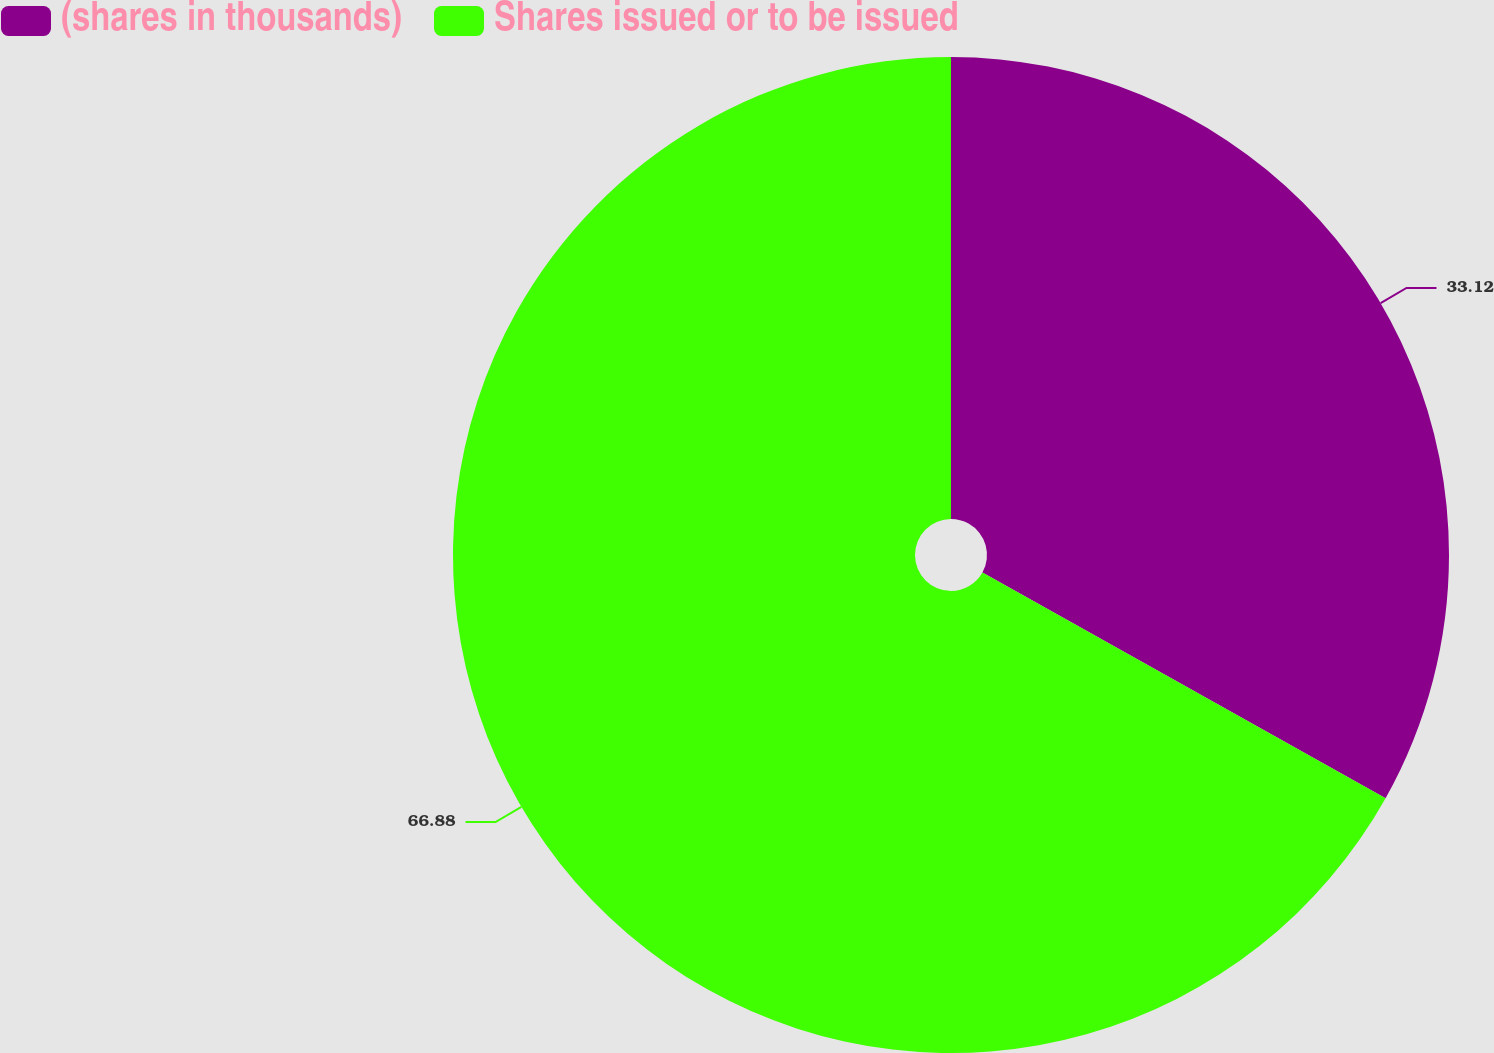<chart> <loc_0><loc_0><loc_500><loc_500><pie_chart><fcel>(shares in thousands)<fcel>Shares issued or to be issued<nl><fcel>33.12%<fcel>66.88%<nl></chart> 